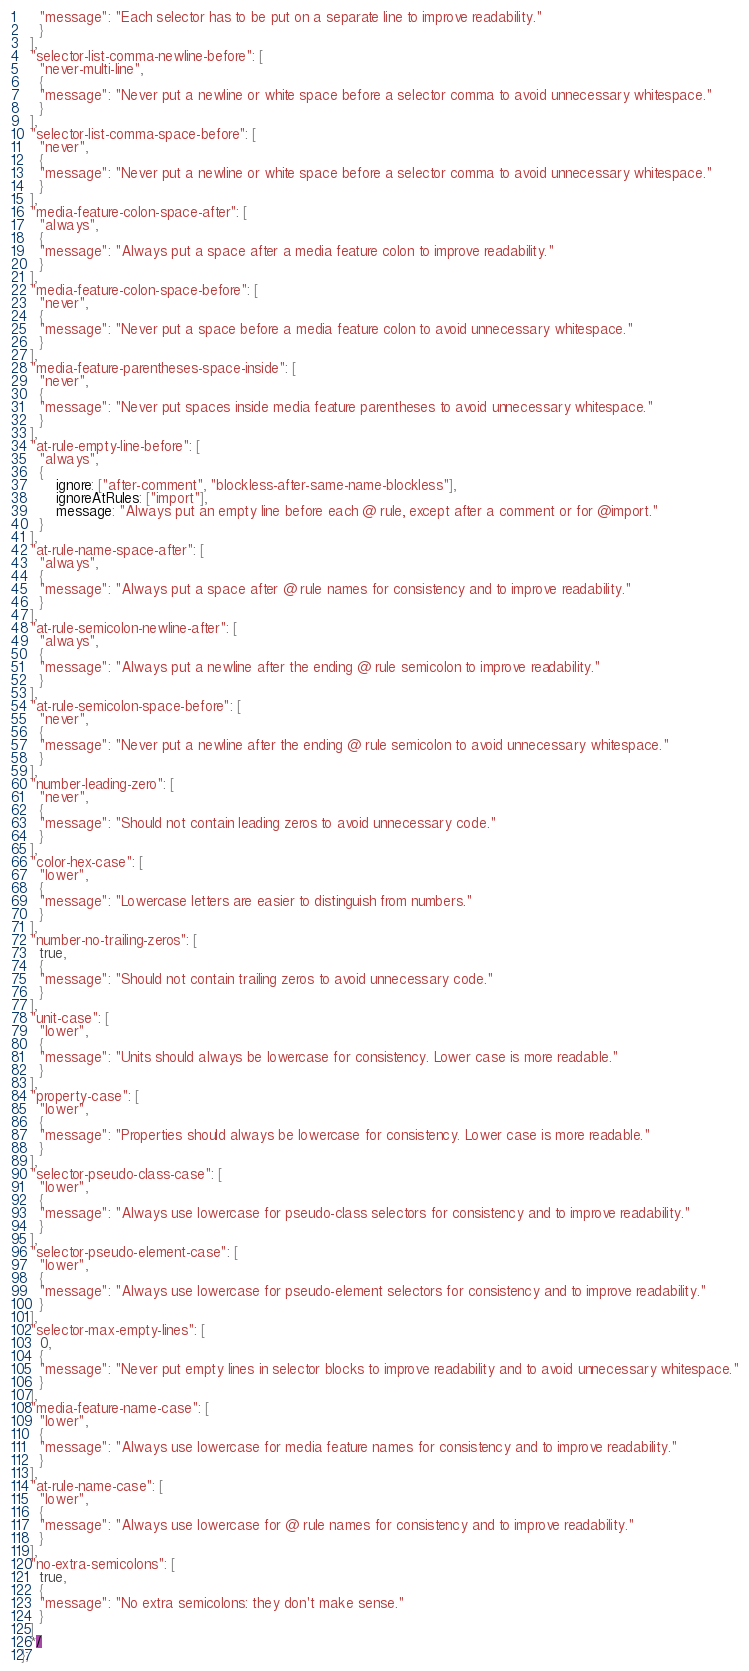Convert code to text. <code><loc_0><loc_0><loc_500><loc_500><_JavaScript_>    "message": "Each selector has to be put on a separate line to improve readability."
    }
  ],
  "selector-list-comma-newline-before": [
    "never-multi-line",
    {
    "message": "Never put a newline or white space before a selector comma to avoid unnecessary whitespace."
    }
  ],
  "selector-list-comma-space-before": [
    "never",
    {
    "message": "Never put a newline or white space before a selector comma to avoid unnecessary whitespace."
    }
  ],
  "media-feature-colon-space-after": [
    "always",
    {
    "message": "Always put a space after a media feature colon to improve readability."
    }
  ],
  "media-feature-colon-space-before": [
    "never",
    {
    "message": "Never put a space before a media feature colon to avoid unnecessary whitespace."
    }
  ],
  "media-feature-parentheses-space-inside": [
    "never",
    {
    "message": "Never put spaces inside media feature parentheses to avoid unnecessary whitespace."
    }
  ],
  "at-rule-empty-line-before": [
	"always",
	{
		ignore: ["after-comment", "blockless-after-same-name-blockless"],
		ignoreAtRules: ["import"],
		message: "Always put an empty line before each @ rule, except after a comment or for @import."
	}
  ],
  "at-rule-name-space-after": [
    "always",
    {
    "message": "Always put a space after @ rule names for consistency and to improve readability."
    }
  ],
  "at-rule-semicolon-newline-after": [
    "always",
    {
    "message": "Always put a newline after the ending @ rule semicolon to improve readability."
    }
  ],
  "at-rule-semicolon-space-before": [
    "never",
    {
    "message": "Never put a newline after the ending @ rule semicolon to avoid unnecessary whitespace."
    }
  ],
  "number-leading-zero": [
    "never",
    {
    "message": "Should not contain leading zeros to avoid unnecessary code."
    }
  ],
  "color-hex-case": [
    "lower",
    {
    "message": "Lowercase letters are easier to distinguish from numbers."
    }
  ],
  "number-no-trailing-zeros": [
    true,
    {
    "message": "Should not contain trailing zeros to avoid unnecessary code."
    }
  ],
  "unit-case": [
    "lower",
    {
    "message": "Units should always be lowercase for consistency. Lower case is more readable."
    }
  ],
  "property-case": [
    "lower",
    {
    "message": "Properties should always be lowercase for consistency. Lower case is more readable."
    }
  ],
  "selector-pseudo-class-case": [
    "lower",
    {
    "message": "Always use lowercase for pseudo-class selectors for consistency and to improve readability."
    }
  ],
  "selector-pseudo-element-case": [
    "lower",
    {
    "message": "Always use lowercase for pseudo-element selectors for consistency and to improve readability."
    }
  ],
  "selector-max-empty-lines": [
    0,
    {
    "message": "Never put empty lines in selector blocks to improve readability and to avoid unnecessary whitespace."
    }
  ],
  "media-feature-name-case": [
    "lower",
    {
    "message": "Always use lowercase for media feature names for consistency and to improve readability."
    }
  ],
  "at-rule-name-case": [
    "lower",
    {
    "message": "Always use lowercase for @ rule names for consistency and to improve readability."
    }
  ],
  "no-extra-semicolons": [
    true,
    {
    "message": "No extra semicolons: they don't make sense."
    }
  ]
  */
};
</code> 